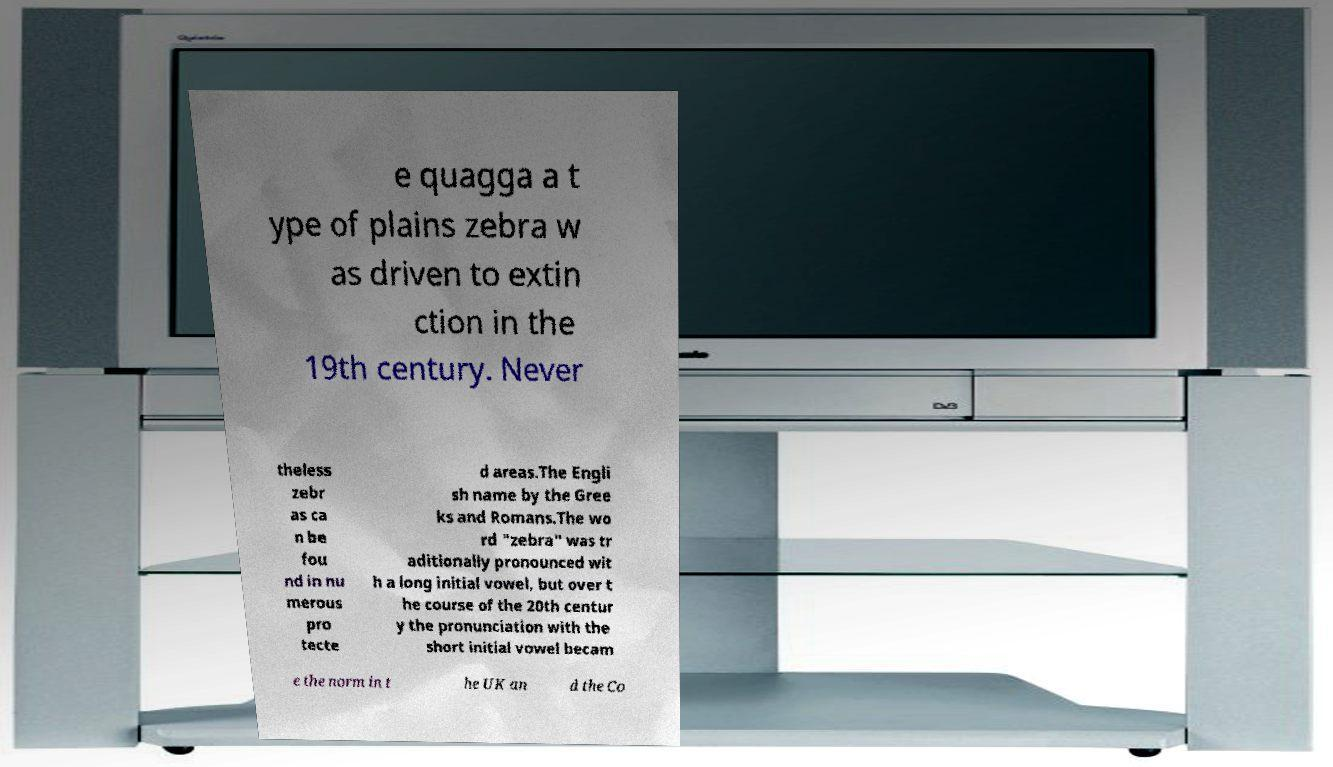What messages or text are displayed in this image? I need them in a readable, typed format. e quagga a t ype of plains zebra w as driven to extin ction in the 19th century. Never theless zebr as ca n be fou nd in nu merous pro tecte d areas.The Engli sh name by the Gree ks and Romans.The wo rd "zebra" was tr aditionally pronounced wit h a long initial vowel, but over t he course of the 20th centur y the pronunciation with the short initial vowel becam e the norm in t he UK an d the Co 